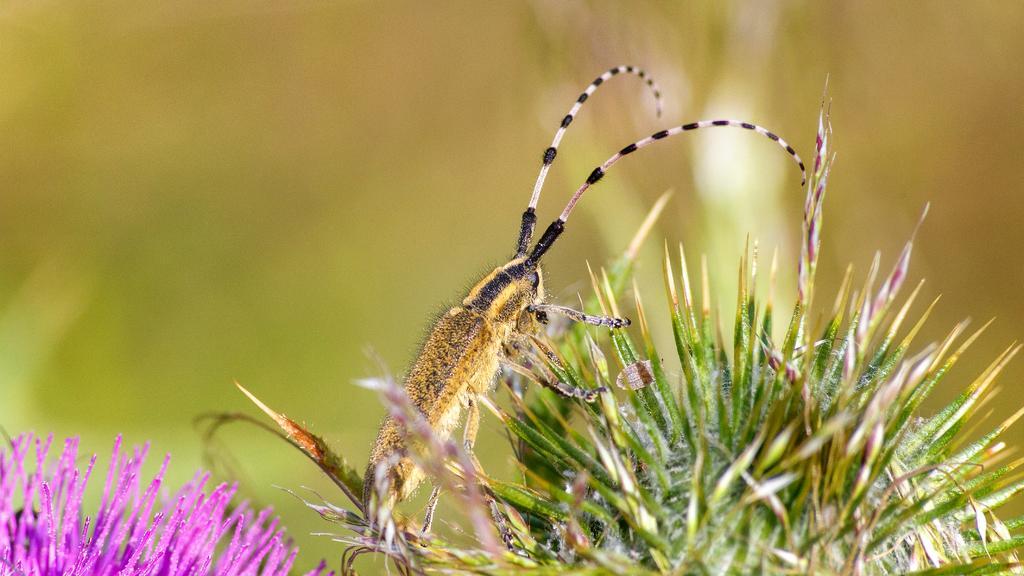Describe this image in one or two sentences. In this image we can see a flower and an insect on the flower and a blurry background. 